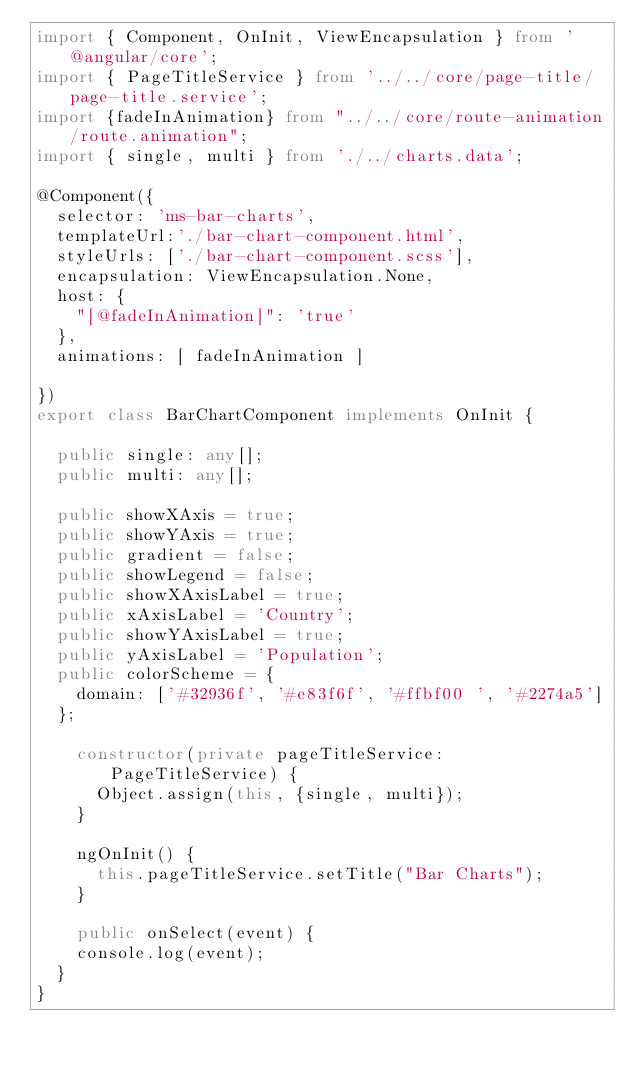<code> <loc_0><loc_0><loc_500><loc_500><_TypeScript_>import { Component, OnInit, ViewEncapsulation } from '@angular/core';
import { PageTitleService } from '../../core/page-title/page-title.service';
import {fadeInAnimation} from "../../core/route-animation/route.animation";
import { single, multi } from './../charts.data';

@Component({
  selector: 'ms-bar-charts',
  templateUrl:'./bar-chart-component.html',
  styleUrls: ['./bar-chart-component.scss'],
  encapsulation: ViewEncapsulation.None,
  host: {
    "[@fadeInAnimation]": 'true'
  },
  animations: [ fadeInAnimation ]
  
})
export class BarChartComponent implements OnInit {

  public single: any[];
  public multi: any[]; 

  public showXAxis = true;
  public showYAxis = true;
  public gradient = false;
  public showLegend = false;
  public showXAxisLabel = true;
  public xAxisLabel = 'Country';
  public showYAxisLabel = true;
  public yAxisLabel = 'Population';
  public colorScheme = {
    domain: ['#32936f', '#e83f6f', '#ffbf00 ', '#2274a5']
  };

    constructor(private pageTitleService: PageTitleService) {
      Object.assign(this, {single, multi});
    }

    ngOnInit() {
      this.pageTitleService.setTitle("Bar Charts");
    }

    public onSelect(event) {
    console.log(event);
  }
}

</code> 